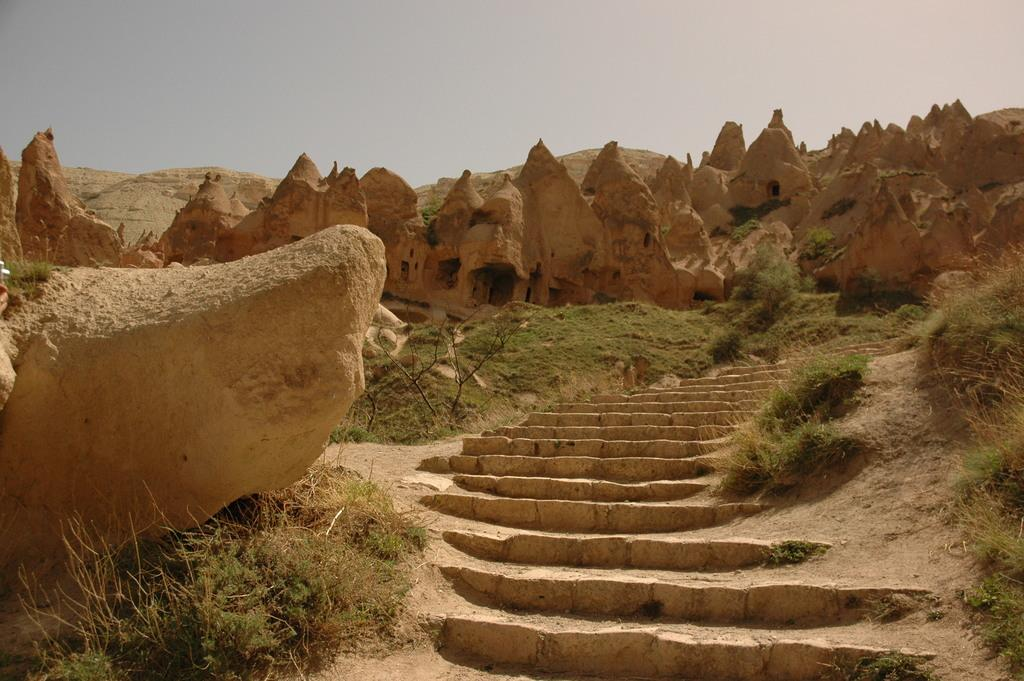What type of natural formation can be seen in the image? There are caves in the image. What architectural feature is present in the image? There are steps in the middle of the image. What type of vegetation is visible in the image? There are plants in the bottom left of the image. What is visible at the top of the image? The sky is visible at the top of the image. What type of vessel is being guided through the motion of the caves in the image? There is no vessel or motion present in the image; it features caves, steps, plants, and the sky. 